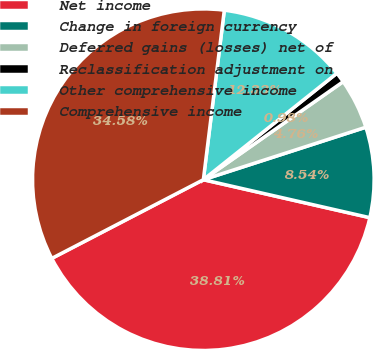Convert chart to OTSL. <chart><loc_0><loc_0><loc_500><loc_500><pie_chart><fcel>Net income<fcel>Change in foreign currency<fcel>Deferred gains (losses) net of<fcel>Reclassification adjustment on<fcel>Other comprehensive income<fcel>Comprehensive income<nl><fcel>38.81%<fcel>8.54%<fcel>4.76%<fcel>0.98%<fcel>12.33%<fcel>34.58%<nl></chart> 